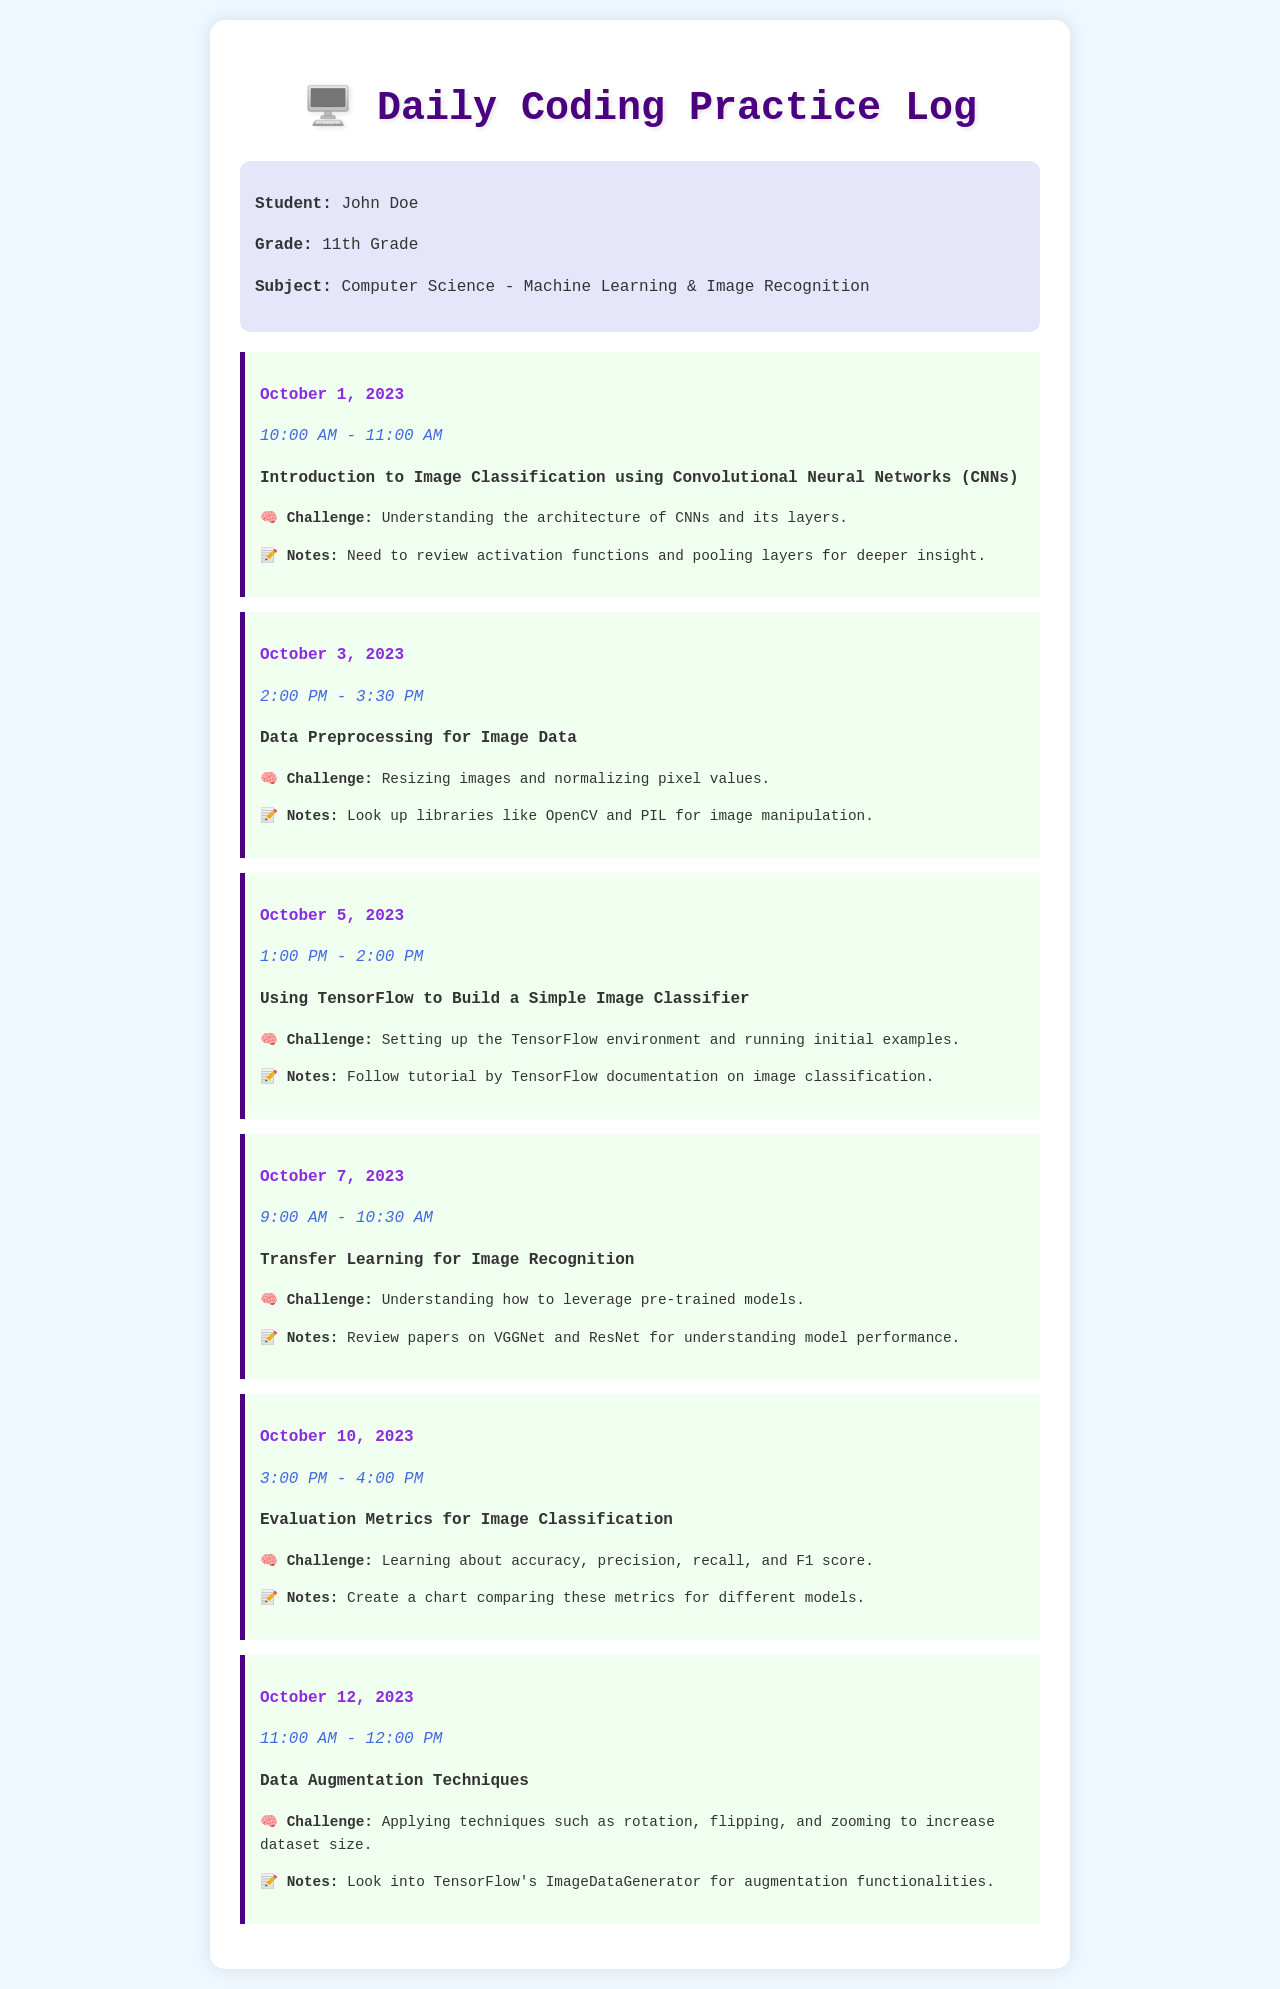What is the student's name? The student's name is listed in the student info section of the log.
Answer: John Doe What is the date of the entry discussing CNNs? The date is mentioned at the beginning of the log entry for CNNs.
Answer: October 1, 2023 What time was the data preprocessing session? The time is specified in the timestamp of the log entry for data preprocessing.
Answer: 2:00 PM - 3:30 PM What challenge was faced regarding transfer learning? The challenge is described in the log entry for transfer learning.
Answer: Understanding how to leverage pre-trained models What are the evaluation metrics covered in the log? The evaluation metrics are detailed in the log entry related to evaluation metrics for image classification.
Answer: Accuracy, precision, recall, and F1 score How long did the session on data augmentation last? The duration of the data augmentation session is noted in its log entry.
Answer: 1 hour What technique is suggested for data augmentation? The log entry lists several techniques to increase dataset size for data augmentation.
Answer: Rotation, flipping, and zooming How many log entries are there in the document? Count the log entries that provide distinct coding practice sessions.
Answer: 6 